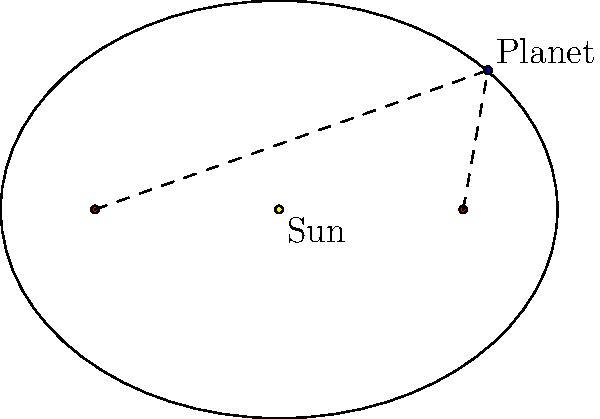Dear, in this diagram of a planet's orbit around the Sun, we see an elliptical path. The Sun is at one focus of the ellipse. Can you tell me what the sum of the distances from the planet to both foci of the ellipse represents? Let's walk through this step-by-step, dear:

1. In an ellipse, there are two special points called foci (singular: focus). In this diagram, the Sun is at one focus, and the other focus is empty.

2. The ellipse represents the path of the planet's orbit around the Sun.

3. A fascinating property of ellipses is that for any point on the ellipse (like where our planet is), the sum of the distances from that point to both foci is always constant.

4. This constant sum is equal to the length of the major axis of the ellipse, which is the longest diameter of the ellipse.

5. In astronomical terms, this means that regardless of where the planet is in its orbit, the sum of its distances to both foci (one being the Sun) remains the same.

6. This constant sum represents the total distance the planet travels in its entire orbit, from its closest approach to the Sun (perihelion) to its farthest point (aphelion) and back again.

7. This property is known as the "constant sum property" of ellipses and is a key feature in understanding planetary orbits as described by Kepler's laws of planetary motion.
Answer: The major axis length of the orbit 